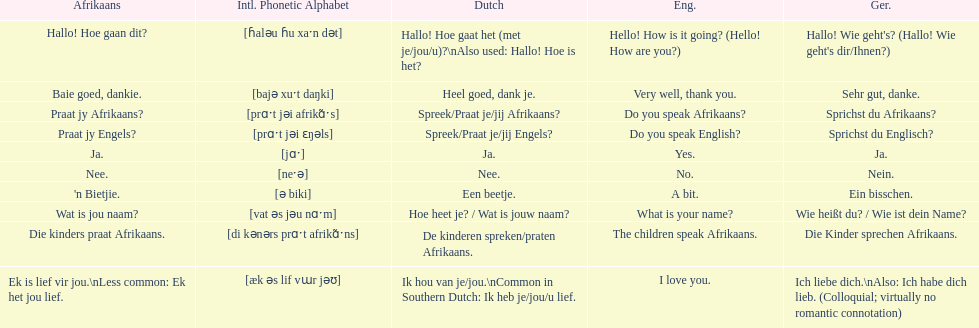What is the way to say 'do you speak afrikaans?' in afrikaans? Praat jy Afrikaans?. 